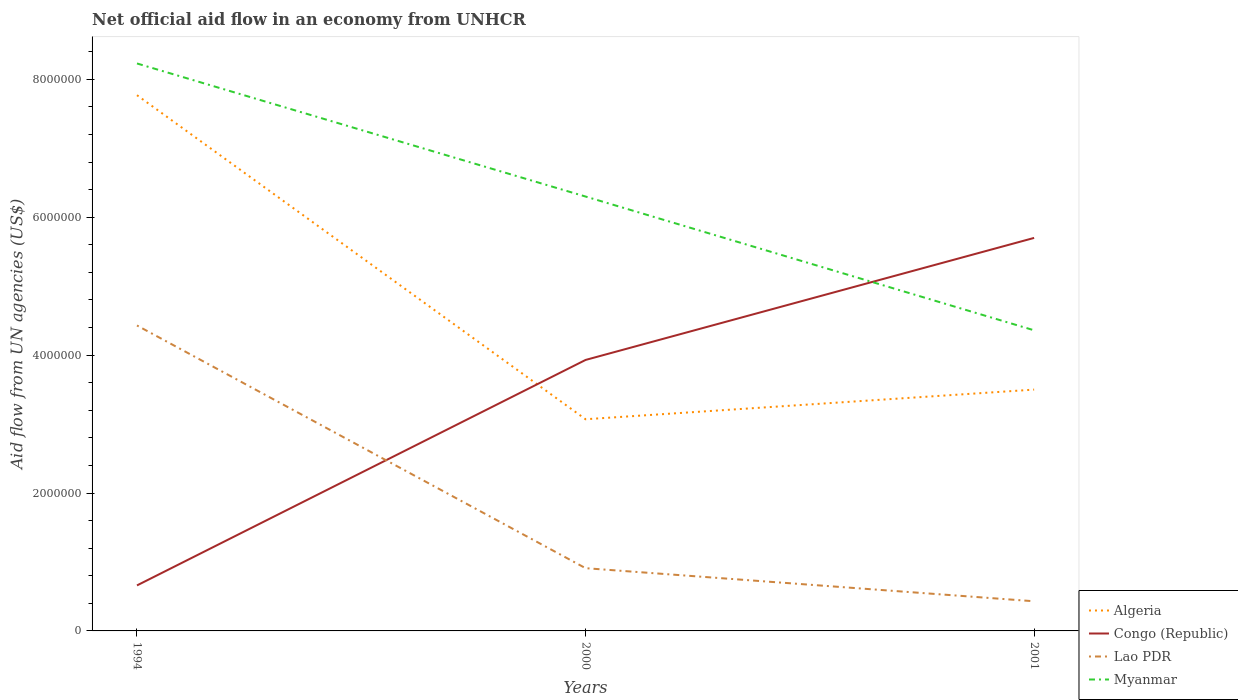Does the line corresponding to Lao PDR intersect with the line corresponding to Algeria?
Your answer should be very brief. No. Is the number of lines equal to the number of legend labels?
Keep it short and to the point. Yes. In which year was the net official aid flow in Myanmar maximum?
Ensure brevity in your answer.  2001. What is the total net official aid flow in Myanmar in the graph?
Your answer should be compact. 1.94e+06. What is the difference between the highest and the second highest net official aid flow in Myanmar?
Ensure brevity in your answer.  3.87e+06. What is the difference between the highest and the lowest net official aid flow in Algeria?
Provide a short and direct response. 1. Does the graph contain any zero values?
Ensure brevity in your answer.  No. Does the graph contain grids?
Make the answer very short. No. Where does the legend appear in the graph?
Provide a short and direct response. Bottom right. How are the legend labels stacked?
Make the answer very short. Vertical. What is the title of the graph?
Make the answer very short. Net official aid flow in an economy from UNHCR. Does "Samoa" appear as one of the legend labels in the graph?
Keep it short and to the point. No. What is the label or title of the X-axis?
Give a very brief answer. Years. What is the label or title of the Y-axis?
Your response must be concise. Aid flow from UN agencies (US$). What is the Aid flow from UN agencies (US$) of Algeria in 1994?
Offer a terse response. 7.77e+06. What is the Aid flow from UN agencies (US$) in Lao PDR in 1994?
Your response must be concise. 4.43e+06. What is the Aid flow from UN agencies (US$) of Myanmar in 1994?
Keep it short and to the point. 8.23e+06. What is the Aid flow from UN agencies (US$) of Algeria in 2000?
Offer a very short reply. 3.07e+06. What is the Aid flow from UN agencies (US$) of Congo (Republic) in 2000?
Keep it short and to the point. 3.93e+06. What is the Aid flow from UN agencies (US$) in Lao PDR in 2000?
Your response must be concise. 9.10e+05. What is the Aid flow from UN agencies (US$) of Myanmar in 2000?
Provide a succinct answer. 6.30e+06. What is the Aid flow from UN agencies (US$) of Algeria in 2001?
Offer a terse response. 3.50e+06. What is the Aid flow from UN agencies (US$) in Congo (Republic) in 2001?
Your answer should be compact. 5.70e+06. What is the Aid flow from UN agencies (US$) in Myanmar in 2001?
Your answer should be very brief. 4.36e+06. Across all years, what is the maximum Aid flow from UN agencies (US$) of Algeria?
Make the answer very short. 7.77e+06. Across all years, what is the maximum Aid flow from UN agencies (US$) in Congo (Republic)?
Your answer should be very brief. 5.70e+06. Across all years, what is the maximum Aid flow from UN agencies (US$) of Lao PDR?
Provide a short and direct response. 4.43e+06. Across all years, what is the maximum Aid flow from UN agencies (US$) of Myanmar?
Ensure brevity in your answer.  8.23e+06. Across all years, what is the minimum Aid flow from UN agencies (US$) in Algeria?
Give a very brief answer. 3.07e+06. Across all years, what is the minimum Aid flow from UN agencies (US$) in Congo (Republic)?
Give a very brief answer. 6.60e+05. Across all years, what is the minimum Aid flow from UN agencies (US$) in Myanmar?
Provide a short and direct response. 4.36e+06. What is the total Aid flow from UN agencies (US$) in Algeria in the graph?
Make the answer very short. 1.43e+07. What is the total Aid flow from UN agencies (US$) of Congo (Republic) in the graph?
Provide a short and direct response. 1.03e+07. What is the total Aid flow from UN agencies (US$) of Lao PDR in the graph?
Make the answer very short. 5.77e+06. What is the total Aid flow from UN agencies (US$) of Myanmar in the graph?
Make the answer very short. 1.89e+07. What is the difference between the Aid flow from UN agencies (US$) of Algeria in 1994 and that in 2000?
Your answer should be compact. 4.70e+06. What is the difference between the Aid flow from UN agencies (US$) in Congo (Republic) in 1994 and that in 2000?
Offer a terse response. -3.27e+06. What is the difference between the Aid flow from UN agencies (US$) of Lao PDR in 1994 and that in 2000?
Offer a terse response. 3.52e+06. What is the difference between the Aid flow from UN agencies (US$) in Myanmar in 1994 and that in 2000?
Your answer should be compact. 1.93e+06. What is the difference between the Aid flow from UN agencies (US$) in Algeria in 1994 and that in 2001?
Provide a short and direct response. 4.27e+06. What is the difference between the Aid flow from UN agencies (US$) of Congo (Republic) in 1994 and that in 2001?
Offer a terse response. -5.04e+06. What is the difference between the Aid flow from UN agencies (US$) of Myanmar in 1994 and that in 2001?
Your response must be concise. 3.87e+06. What is the difference between the Aid flow from UN agencies (US$) of Algeria in 2000 and that in 2001?
Your response must be concise. -4.30e+05. What is the difference between the Aid flow from UN agencies (US$) in Congo (Republic) in 2000 and that in 2001?
Make the answer very short. -1.77e+06. What is the difference between the Aid flow from UN agencies (US$) in Myanmar in 2000 and that in 2001?
Your answer should be compact. 1.94e+06. What is the difference between the Aid flow from UN agencies (US$) of Algeria in 1994 and the Aid flow from UN agencies (US$) of Congo (Republic) in 2000?
Your answer should be compact. 3.84e+06. What is the difference between the Aid flow from UN agencies (US$) in Algeria in 1994 and the Aid flow from UN agencies (US$) in Lao PDR in 2000?
Offer a very short reply. 6.86e+06. What is the difference between the Aid flow from UN agencies (US$) in Algeria in 1994 and the Aid flow from UN agencies (US$) in Myanmar in 2000?
Your answer should be very brief. 1.47e+06. What is the difference between the Aid flow from UN agencies (US$) of Congo (Republic) in 1994 and the Aid flow from UN agencies (US$) of Myanmar in 2000?
Your answer should be compact. -5.64e+06. What is the difference between the Aid flow from UN agencies (US$) in Lao PDR in 1994 and the Aid flow from UN agencies (US$) in Myanmar in 2000?
Provide a succinct answer. -1.87e+06. What is the difference between the Aid flow from UN agencies (US$) of Algeria in 1994 and the Aid flow from UN agencies (US$) of Congo (Republic) in 2001?
Ensure brevity in your answer.  2.07e+06. What is the difference between the Aid flow from UN agencies (US$) in Algeria in 1994 and the Aid flow from UN agencies (US$) in Lao PDR in 2001?
Offer a terse response. 7.34e+06. What is the difference between the Aid flow from UN agencies (US$) in Algeria in 1994 and the Aid flow from UN agencies (US$) in Myanmar in 2001?
Your response must be concise. 3.41e+06. What is the difference between the Aid flow from UN agencies (US$) of Congo (Republic) in 1994 and the Aid flow from UN agencies (US$) of Lao PDR in 2001?
Keep it short and to the point. 2.30e+05. What is the difference between the Aid flow from UN agencies (US$) of Congo (Republic) in 1994 and the Aid flow from UN agencies (US$) of Myanmar in 2001?
Ensure brevity in your answer.  -3.70e+06. What is the difference between the Aid flow from UN agencies (US$) in Algeria in 2000 and the Aid flow from UN agencies (US$) in Congo (Republic) in 2001?
Make the answer very short. -2.63e+06. What is the difference between the Aid flow from UN agencies (US$) of Algeria in 2000 and the Aid flow from UN agencies (US$) of Lao PDR in 2001?
Your response must be concise. 2.64e+06. What is the difference between the Aid flow from UN agencies (US$) in Algeria in 2000 and the Aid flow from UN agencies (US$) in Myanmar in 2001?
Your answer should be compact. -1.29e+06. What is the difference between the Aid flow from UN agencies (US$) of Congo (Republic) in 2000 and the Aid flow from UN agencies (US$) of Lao PDR in 2001?
Your answer should be compact. 3.50e+06. What is the difference between the Aid flow from UN agencies (US$) in Congo (Republic) in 2000 and the Aid flow from UN agencies (US$) in Myanmar in 2001?
Provide a short and direct response. -4.30e+05. What is the difference between the Aid flow from UN agencies (US$) in Lao PDR in 2000 and the Aid flow from UN agencies (US$) in Myanmar in 2001?
Your response must be concise. -3.45e+06. What is the average Aid flow from UN agencies (US$) in Algeria per year?
Your answer should be very brief. 4.78e+06. What is the average Aid flow from UN agencies (US$) of Congo (Republic) per year?
Ensure brevity in your answer.  3.43e+06. What is the average Aid flow from UN agencies (US$) of Lao PDR per year?
Offer a very short reply. 1.92e+06. What is the average Aid flow from UN agencies (US$) in Myanmar per year?
Provide a short and direct response. 6.30e+06. In the year 1994, what is the difference between the Aid flow from UN agencies (US$) of Algeria and Aid flow from UN agencies (US$) of Congo (Republic)?
Ensure brevity in your answer.  7.11e+06. In the year 1994, what is the difference between the Aid flow from UN agencies (US$) of Algeria and Aid flow from UN agencies (US$) of Lao PDR?
Provide a succinct answer. 3.34e+06. In the year 1994, what is the difference between the Aid flow from UN agencies (US$) in Algeria and Aid flow from UN agencies (US$) in Myanmar?
Your answer should be very brief. -4.60e+05. In the year 1994, what is the difference between the Aid flow from UN agencies (US$) in Congo (Republic) and Aid flow from UN agencies (US$) in Lao PDR?
Provide a succinct answer. -3.77e+06. In the year 1994, what is the difference between the Aid flow from UN agencies (US$) in Congo (Republic) and Aid flow from UN agencies (US$) in Myanmar?
Your answer should be very brief. -7.57e+06. In the year 1994, what is the difference between the Aid flow from UN agencies (US$) in Lao PDR and Aid flow from UN agencies (US$) in Myanmar?
Provide a short and direct response. -3.80e+06. In the year 2000, what is the difference between the Aid flow from UN agencies (US$) in Algeria and Aid flow from UN agencies (US$) in Congo (Republic)?
Make the answer very short. -8.60e+05. In the year 2000, what is the difference between the Aid flow from UN agencies (US$) of Algeria and Aid flow from UN agencies (US$) of Lao PDR?
Offer a terse response. 2.16e+06. In the year 2000, what is the difference between the Aid flow from UN agencies (US$) of Algeria and Aid flow from UN agencies (US$) of Myanmar?
Keep it short and to the point. -3.23e+06. In the year 2000, what is the difference between the Aid flow from UN agencies (US$) of Congo (Republic) and Aid flow from UN agencies (US$) of Lao PDR?
Offer a very short reply. 3.02e+06. In the year 2000, what is the difference between the Aid flow from UN agencies (US$) in Congo (Republic) and Aid flow from UN agencies (US$) in Myanmar?
Your response must be concise. -2.37e+06. In the year 2000, what is the difference between the Aid flow from UN agencies (US$) in Lao PDR and Aid flow from UN agencies (US$) in Myanmar?
Give a very brief answer. -5.39e+06. In the year 2001, what is the difference between the Aid flow from UN agencies (US$) in Algeria and Aid flow from UN agencies (US$) in Congo (Republic)?
Provide a short and direct response. -2.20e+06. In the year 2001, what is the difference between the Aid flow from UN agencies (US$) of Algeria and Aid flow from UN agencies (US$) of Lao PDR?
Give a very brief answer. 3.07e+06. In the year 2001, what is the difference between the Aid flow from UN agencies (US$) of Algeria and Aid flow from UN agencies (US$) of Myanmar?
Offer a very short reply. -8.60e+05. In the year 2001, what is the difference between the Aid flow from UN agencies (US$) of Congo (Republic) and Aid flow from UN agencies (US$) of Lao PDR?
Ensure brevity in your answer.  5.27e+06. In the year 2001, what is the difference between the Aid flow from UN agencies (US$) in Congo (Republic) and Aid flow from UN agencies (US$) in Myanmar?
Offer a very short reply. 1.34e+06. In the year 2001, what is the difference between the Aid flow from UN agencies (US$) of Lao PDR and Aid flow from UN agencies (US$) of Myanmar?
Offer a very short reply. -3.93e+06. What is the ratio of the Aid flow from UN agencies (US$) in Algeria in 1994 to that in 2000?
Offer a terse response. 2.53. What is the ratio of the Aid flow from UN agencies (US$) of Congo (Republic) in 1994 to that in 2000?
Keep it short and to the point. 0.17. What is the ratio of the Aid flow from UN agencies (US$) in Lao PDR in 1994 to that in 2000?
Provide a succinct answer. 4.87. What is the ratio of the Aid flow from UN agencies (US$) of Myanmar in 1994 to that in 2000?
Your answer should be compact. 1.31. What is the ratio of the Aid flow from UN agencies (US$) in Algeria in 1994 to that in 2001?
Provide a succinct answer. 2.22. What is the ratio of the Aid flow from UN agencies (US$) in Congo (Republic) in 1994 to that in 2001?
Your response must be concise. 0.12. What is the ratio of the Aid flow from UN agencies (US$) in Lao PDR in 1994 to that in 2001?
Ensure brevity in your answer.  10.3. What is the ratio of the Aid flow from UN agencies (US$) in Myanmar in 1994 to that in 2001?
Your response must be concise. 1.89. What is the ratio of the Aid flow from UN agencies (US$) in Algeria in 2000 to that in 2001?
Make the answer very short. 0.88. What is the ratio of the Aid flow from UN agencies (US$) of Congo (Republic) in 2000 to that in 2001?
Your answer should be compact. 0.69. What is the ratio of the Aid flow from UN agencies (US$) of Lao PDR in 2000 to that in 2001?
Ensure brevity in your answer.  2.12. What is the ratio of the Aid flow from UN agencies (US$) in Myanmar in 2000 to that in 2001?
Make the answer very short. 1.45. What is the difference between the highest and the second highest Aid flow from UN agencies (US$) in Algeria?
Ensure brevity in your answer.  4.27e+06. What is the difference between the highest and the second highest Aid flow from UN agencies (US$) in Congo (Republic)?
Offer a very short reply. 1.77e+06. What is the difference between the highest and the second highest Aid flow from UN agencies (US$) in Lao PDR?
Keep it short and to the point. 3.52e+06. What is the difference between the highest and the second highest Aid flow from UN agencies (US$) of Myanmar?
Offer a very short reply. 1.93e+06. What is the difference between the highest and the lowest Aid flow from UN agencies (US$) of Algeria?
Provide a succinct answer. 4.70e+06. What is the difference between the highest and the lowest Aid flow from UN agencies (US$) in Congo (Republic)?
Your answer should be very brief. 5.04e+06. What is the difference between the highest and the lowest Aid flow from UN agencies (US$) of Myanmar?
Offer a very short reply. 3.87e+06. 